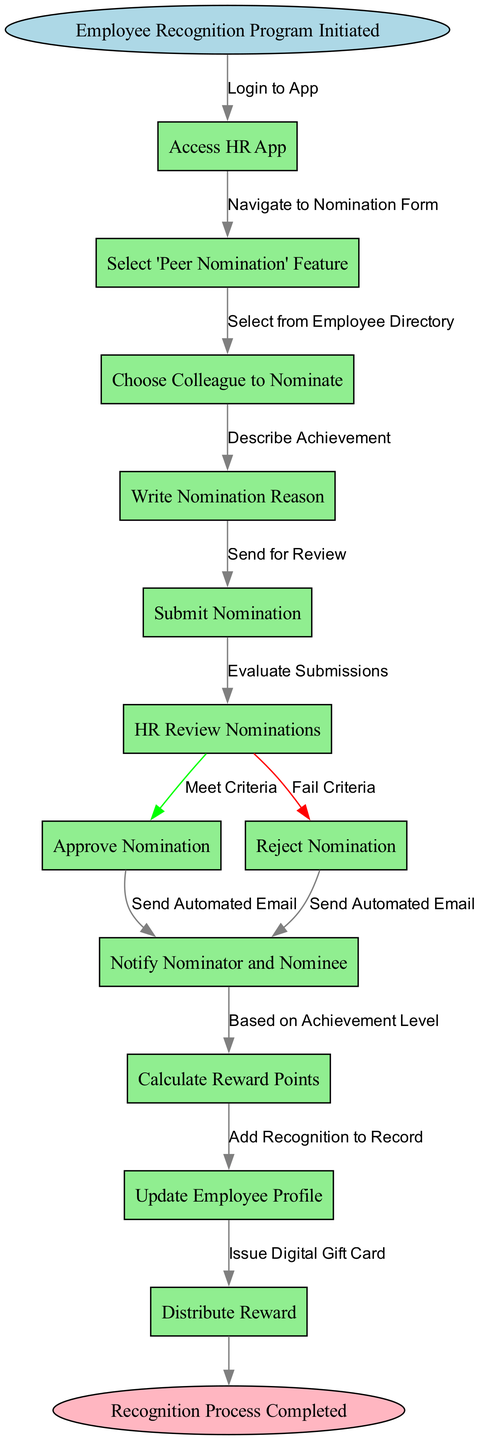What is the first step in the recognition program? The first step in the diagram is represented by the node labeled 'Employee Recognition Program Initiated', which denotes the initiation of the process.
Answer: Employee Recognition Program Initiated How many nodes are in the flow chart? By counting the distinct nodes listed in the diagram (including start and end), we find that there are a total of 12 nodes.
Answer: 12 What happens after submitting a nomination? After submitting a nomination, the next node is 'HR Review Nominations', indicating that this is the subsequent step in the flow.
Answer: HR Review Nominations What are the two outcomes of the HR review? The HR review leads to two outcomes, which are 'Approve Nomination' and 'Reject Nomination', indicating successful or unsuccessful evaluation of the nominations.
Answer: Approve Nomination and Reject Nomination How many edges are there connecting the nodes? To determine the number of edges, we can count the connections between the nodes. There are a total of 11 edges going from one node to another within this flow chart.
Answer: 11 What is the final step in the recognition process? The final step as shown at the end of the diagram is labeled 'Recognition Process Completed', which signifies the conclusion of the entire process.
Answer: Recognition Process Completed What is the action taken after a nomination is approved? Once a nomination is approved, the following action is to 'Calculate Reward Points', signifying the next process in reward distribution.
Answer: Calculate Reward Points If a nomination is rejected, what happens next? In the event a nomination is rejected, the next action taken is to 'Notify Nominator and Nominee', which informs both parties of the decision.
Answer: Notify Nominator and Nominee What does the node 'Update Employee Profile' represent in the flow? The node 'Update Employee Profile' represents the action of recording the recognition once the reward points have been calculated and the nomination is approved.
Answer: Update Employee Profile 